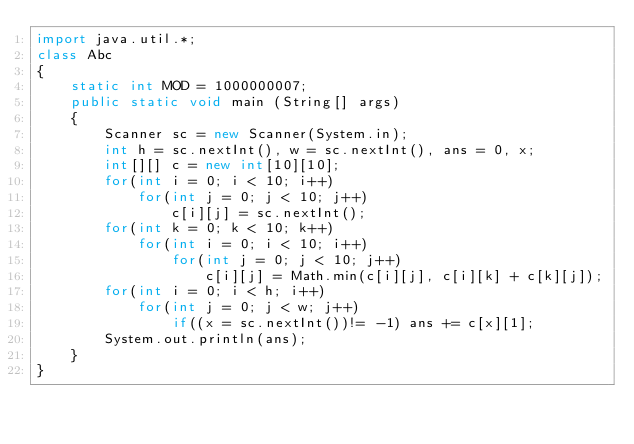Convert code to text. <code><loc_0><loc_0><loc_500><loc_500><_Java_>import java.util.*;
class Abc
{
    static int MOD = 1000000007;
    public static void main (String[] args)
    {
        Scanner sc = new Scanner(System.in);
        int h = sc.nextInt(), w = sc.nextInt(), ans = 0, x;
        int[][] c = new int[10][10];
        for(int i = 0; i < 10; i++)
            for(int j = 0; j < 10; j++)
                c[i][j] = sc.nextInt();
        for(int k = 0; k < 10; k++)
            for(int i = 0; i < 10; i++)
                for(int j = 0; j < 10; j++)
                    c[i][j] = Math.min(c[i][j], c[i][k] + c[k][j]);
        for(int i = 0; i < h; i++)
            for(int j = 0; j < w; j++)
                if((x = sc.nextInt())!= -1) ans += c[x][1];
        System.out.println(ans);
    }
}</code> 